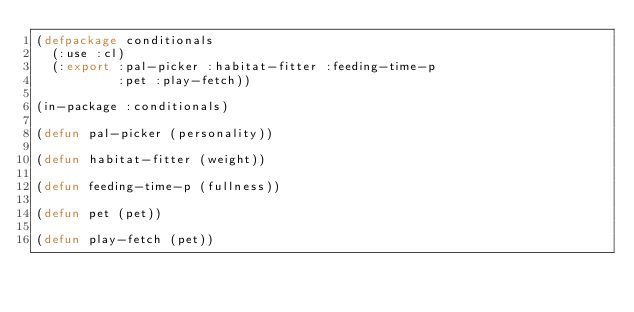<code> <loc_0><loc_0><loc_500><loc_500><_Lisp_>(defpackage conditionals
  (:use :cl)
  (:export :pal-picker :habitat-fitter :feeding-time-p
           :pet :play-fetch))

(in-package :conditionals)

(defun pal-picker (personality))

(defun habitat-fitter (weight))

(defun feeding-time-p (fullness))

(defun pet (pet))

(defun play-fetch (pet))
</code> 